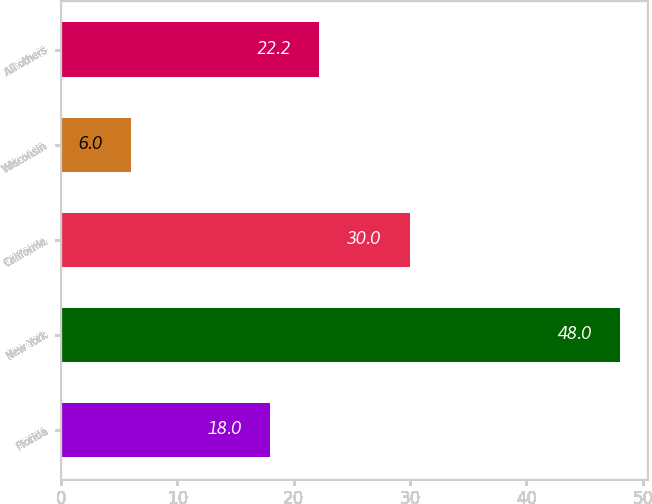Convert chart. <chart><loc_0><loc_0><loc_500><loc_500><bar_chart><fcel>Florida<fcel>New York<fcel>California<fcel>Wisconsin<fcel>All others<nl><fcel>18<fcel>48<fcel>30<fcel>6<fcel>22.2<nl></chart> 